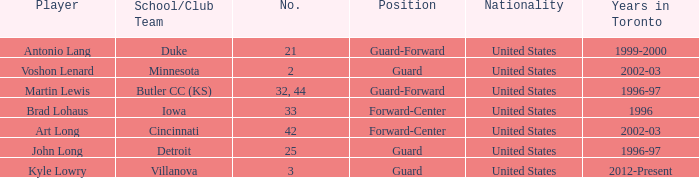Who is the player that wears number 42? Art Long. 